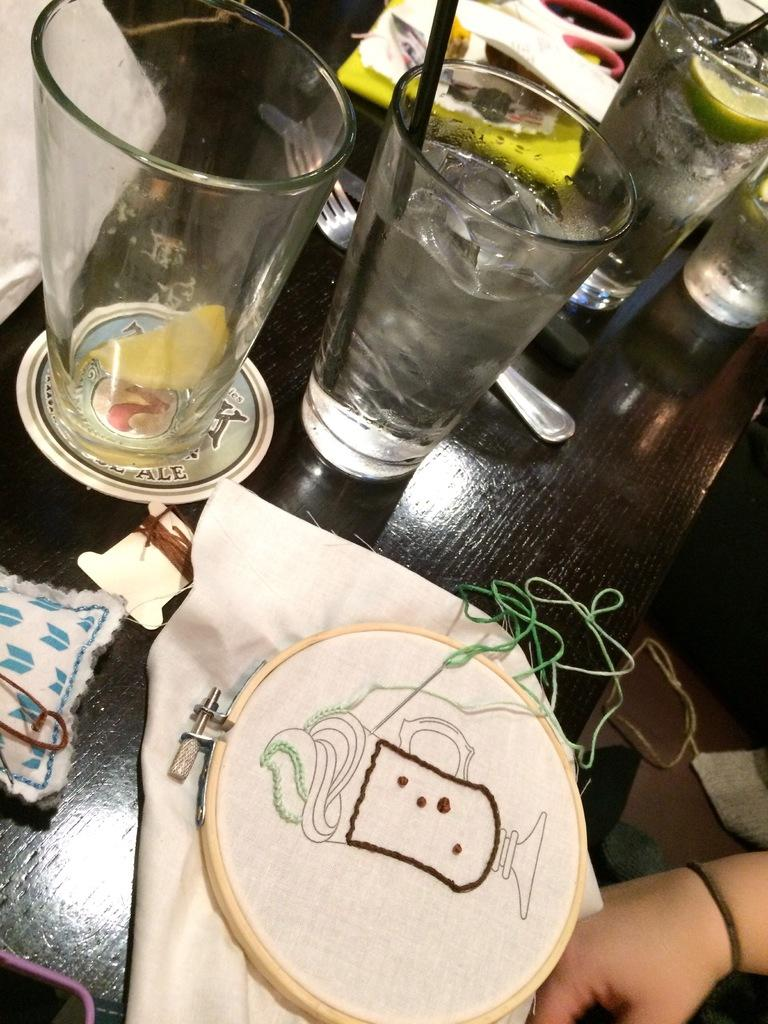What type of tableware can be seen on the table in the image? There are glasses and spoons on the table in the image. What type of material is the cloth visible in the image made of? The cloth visible in the image is made of an unspecified material. What is the wooden object in the image? The wooden object in the image is not described in detail, so we cannot determine its specific purpose or function. Can you describe the person's hand visible on the right side of the image? The person's hand visible on the right side of the image is not described in detail, so we cannot determine its specific position or action. What type of ink is being used to write songs on the table in the image? There is no ink or writing present in the image, and no songs are being written or performed. 